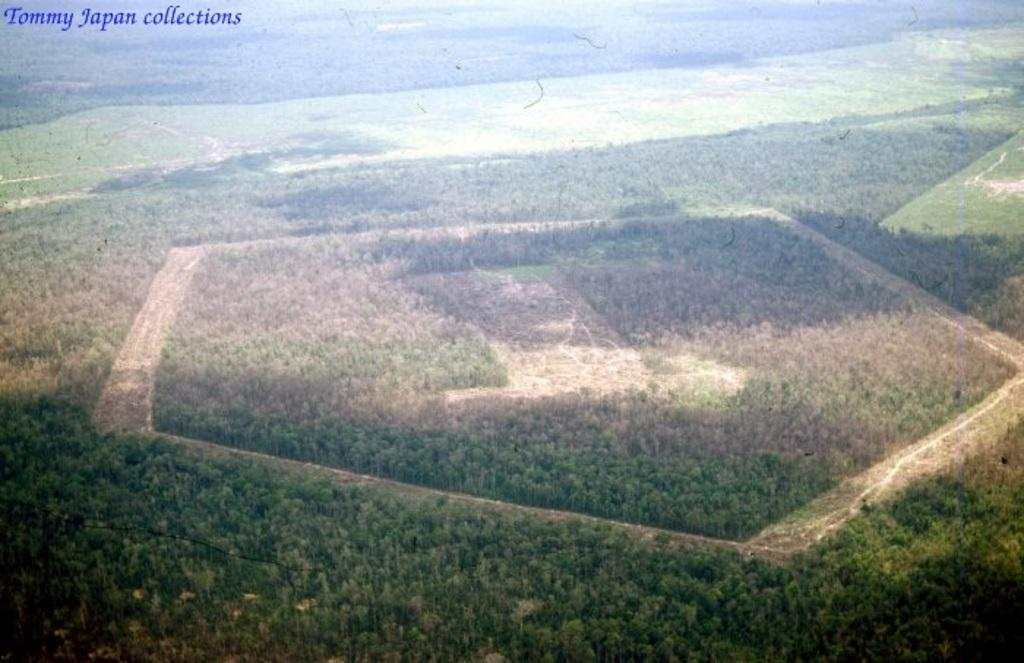What perspective is the image taken from? The image is taken from a top view. What type of natural elements can be seen in the image? There are trees visible in the image. What type of loaf is being baked in the oven in the image? There is no oven or loaf present in the image; it only shows trees from a top view. 